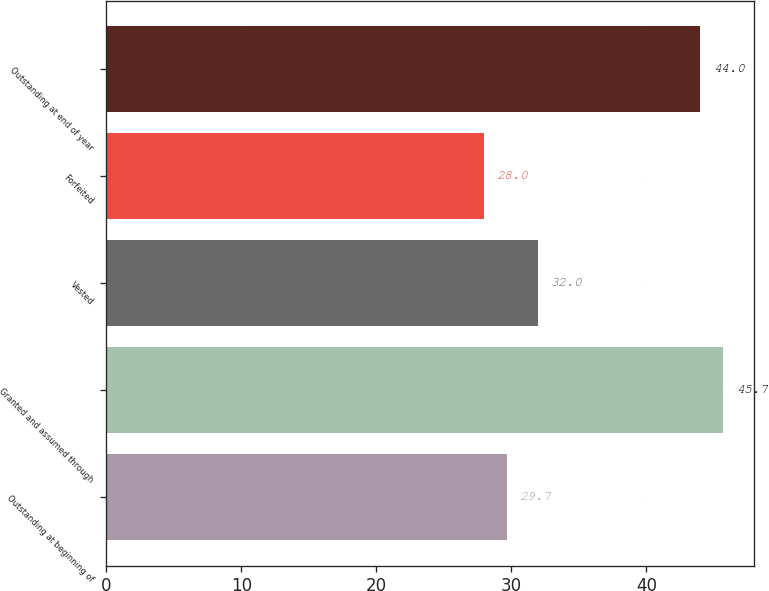Convert chart to OTSL. <chart><loc_0><loc_0><loc_500><loc_500><bar_chart><fcel>Outstanding at beginning of<fcel>Granted and assumed through<fcel>Vested<fcel>Forfeited<fcel>Outstanding at end of year<nl><fcel>29.7<fcel>45.7<fcel>32<fcel>28<fcel>44<nl></chart> 